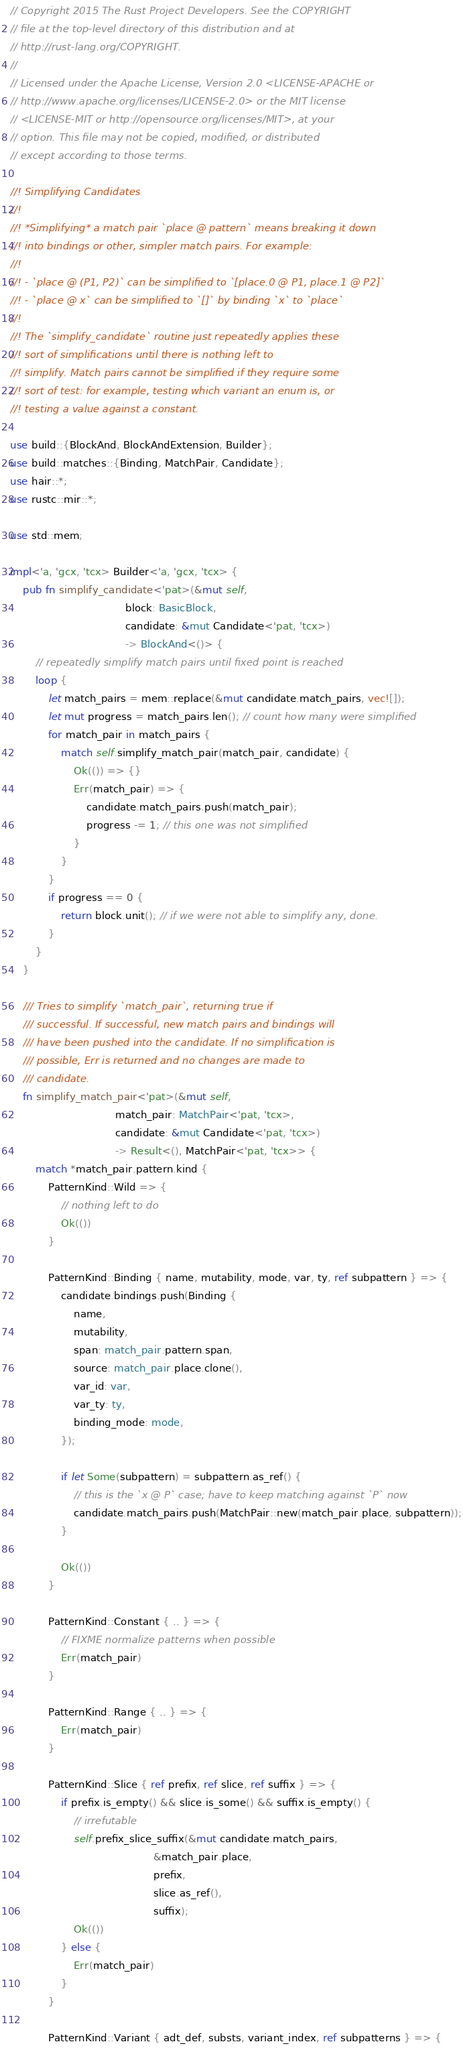<code> <loc_0><loc_0><loc_500><loc_500><_Rust_>// Copyright 2015 The Rust Project Developers. See the COPYRIGHT
// file at the top-level directory of this distribution and at
// http://rust-lang.org/COPYRIGHT.
//
// Licensed under the Apache License, Version 2.0 <LICENSE-APACHE or
// http://www.apache.org/licenses/LICENSE-2.0> or the MIT license
// <LICENSE-MIT or http://opensource.org/licenses/MIT>, at your
// option. This file may not be copied, modified, or distributed
// except according to those terms.

//! Simplifying Candidates
//!
//! *Simplifying* a match pair `place @ pattern` means breaking it down
//! into bindings or other, simpler match pairs. For example:
//!
//! - `place @ (P1, P2)` can be simplified to `[place.0 @ P1, place.1 @ P2]`
//! - `place @ x` can be simplified to `[]` by binding `x` to `place`
//!
//! The `simplify_candidate` routine just repeatedly applies these
//! sort of simplifications until there is nothing left to
//! simplify. Match pairs cannot be simplified if they require some
//! sort of test: for example, testing which variant an enum is, or
//! testing a value against a constant.

use build::{BlockAnd, BlockAndExtension, Builder};
use build::matches::{Binding, MatchPair, Candidate};
use hair::*;
use rustc::mir::*;

use std::mem;

impl<'a, 'gcx, 'tcx> Builder<'a, 'gcx, 'tcx> {
    pub fn simplify_candidate<'pat>(&mut self,
                                    block: BasicBlock,
                                    candidate: &mut Candidate<'pat, 'tcx>)
                                    -> BlockAnd<()> {
        // repeatedly simplify match pairs until fixed point is reached
        loop {
            let match_pairs = mem::replace(&mut candidate.match_pairs, vec![]);
            let mut progress = match_pairs.len(); // count how many were simplified
            for match_pair in match_pairs {
                match self.simplify_match_pair(match_pair, candidate) {
                    Ok(()) => {}
                    Err(match_pair) => {
                        candidate.match_pairs.push(match_pair);
                        progress -= 1; // this one was not simplified
                    }
                }
            }
            if progress == 0 {
                return block.unit(); // if we were not able to simplify any, done.
            }
        }
    }

    /// Tries to simplify `match_pair`, returning true if
    /// successful. If successful, new match pairs and bindings will
    /// have been pushed into the candidate. If no simplification is
    /// possible, Err is returned and no changes are made to
    /// candidate.
    fn simplify_match_pair<'pat>(&mut self,
                                 match_pair: MatchPair<'pat, 'tcx>,
                                 candidate: &mut Candidate<'pat, 'tcx>)
                                 -> Result<(), MatchPair<'pat, 'tcx>> {
        match *match_pair.pattern.kind {
            PatternKind::Wild => {
                // nothing left to do
                Ok(())
            }

            PatternKind::Binding { name, mutability, mode, var, ty, ref subpattern } => {
                candidate.bindings.push(Binding {
                    name,
                    mutability,
                    span: match_pair.pattern.span,
                    source: match_pair.place.clone(),
                    var_id: var,
                    var_ty: ty,
                    binding_mode: mode,
                });

                if let Some(subpattern) = subpattern.as_ref() {
                    // this is the `x @ P` case; have to keep matching against `P` now
                    candidate.match_pairs.push(MatchPair::new(match_pair.place, subpattern));
                }

                Ok(())
            }

            PatternKind::Constant { .. } => {
                // FIXME normalize patterns when possible
                Err(match_pair)
            }

            PatternKind::Range { .. } => {
                Err(match_pair)
            }

            PatternKind::Slice { ref prefix, ref slice, ref suffix } => {
                if prefix.is_empty() && slice.is_some() && suffix.is_empty() {
                    // irrefutable
                    self.prefix_slice_suffix(&mut candidate.match_pairs,
                                             &match_pair.place,
                                             prefix,
                                             slice.as_ref(),
                                             suffix);
                    Ok(())
                } else {
                    Err(match_pair)
                }
            }

            PatternKind::Variant { adt_def, substs, variant_index, ref subpatterns } => {</code> 